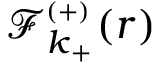Convert formula to latex. <formula><loc_0><loc_0><loc_500><loc_500>{ \mathcal { F } _ { k _ { + } } ^ { _ { ( + ) } } ( r ) }</formula> 